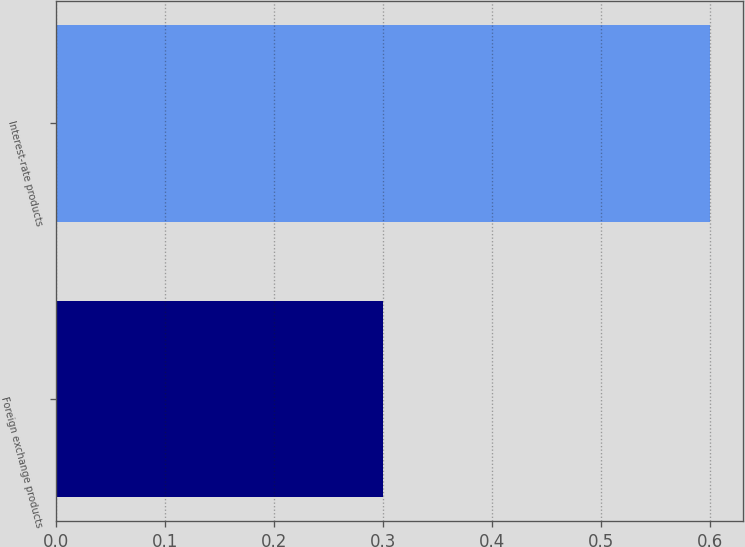Convert chart. <chart><loc_0><loc_0><loc_500><loc_500><bar_chart><fcel>Foreign exchange products<fcel>Interest-rate products<nl><fcel>0.3<fcel>0.6<nl></chart> 